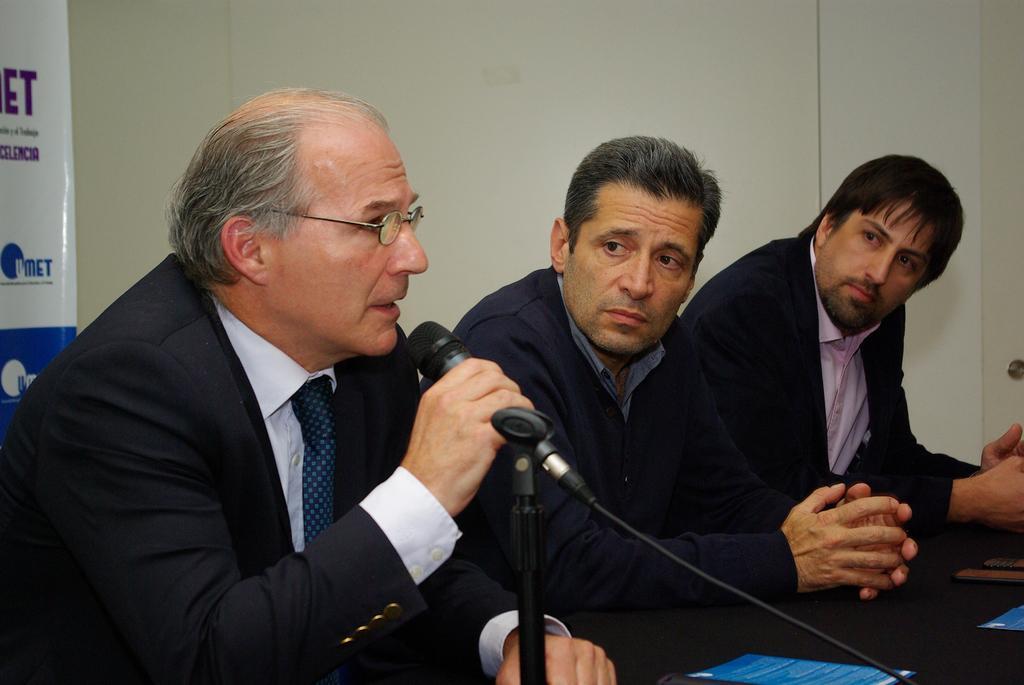Can you describe this image briefly? Here we can see three men. He has spectacles and he is talking on the mike. This is table. On the table there are papers and mobiles. In the background we can see a wall and a banner. 